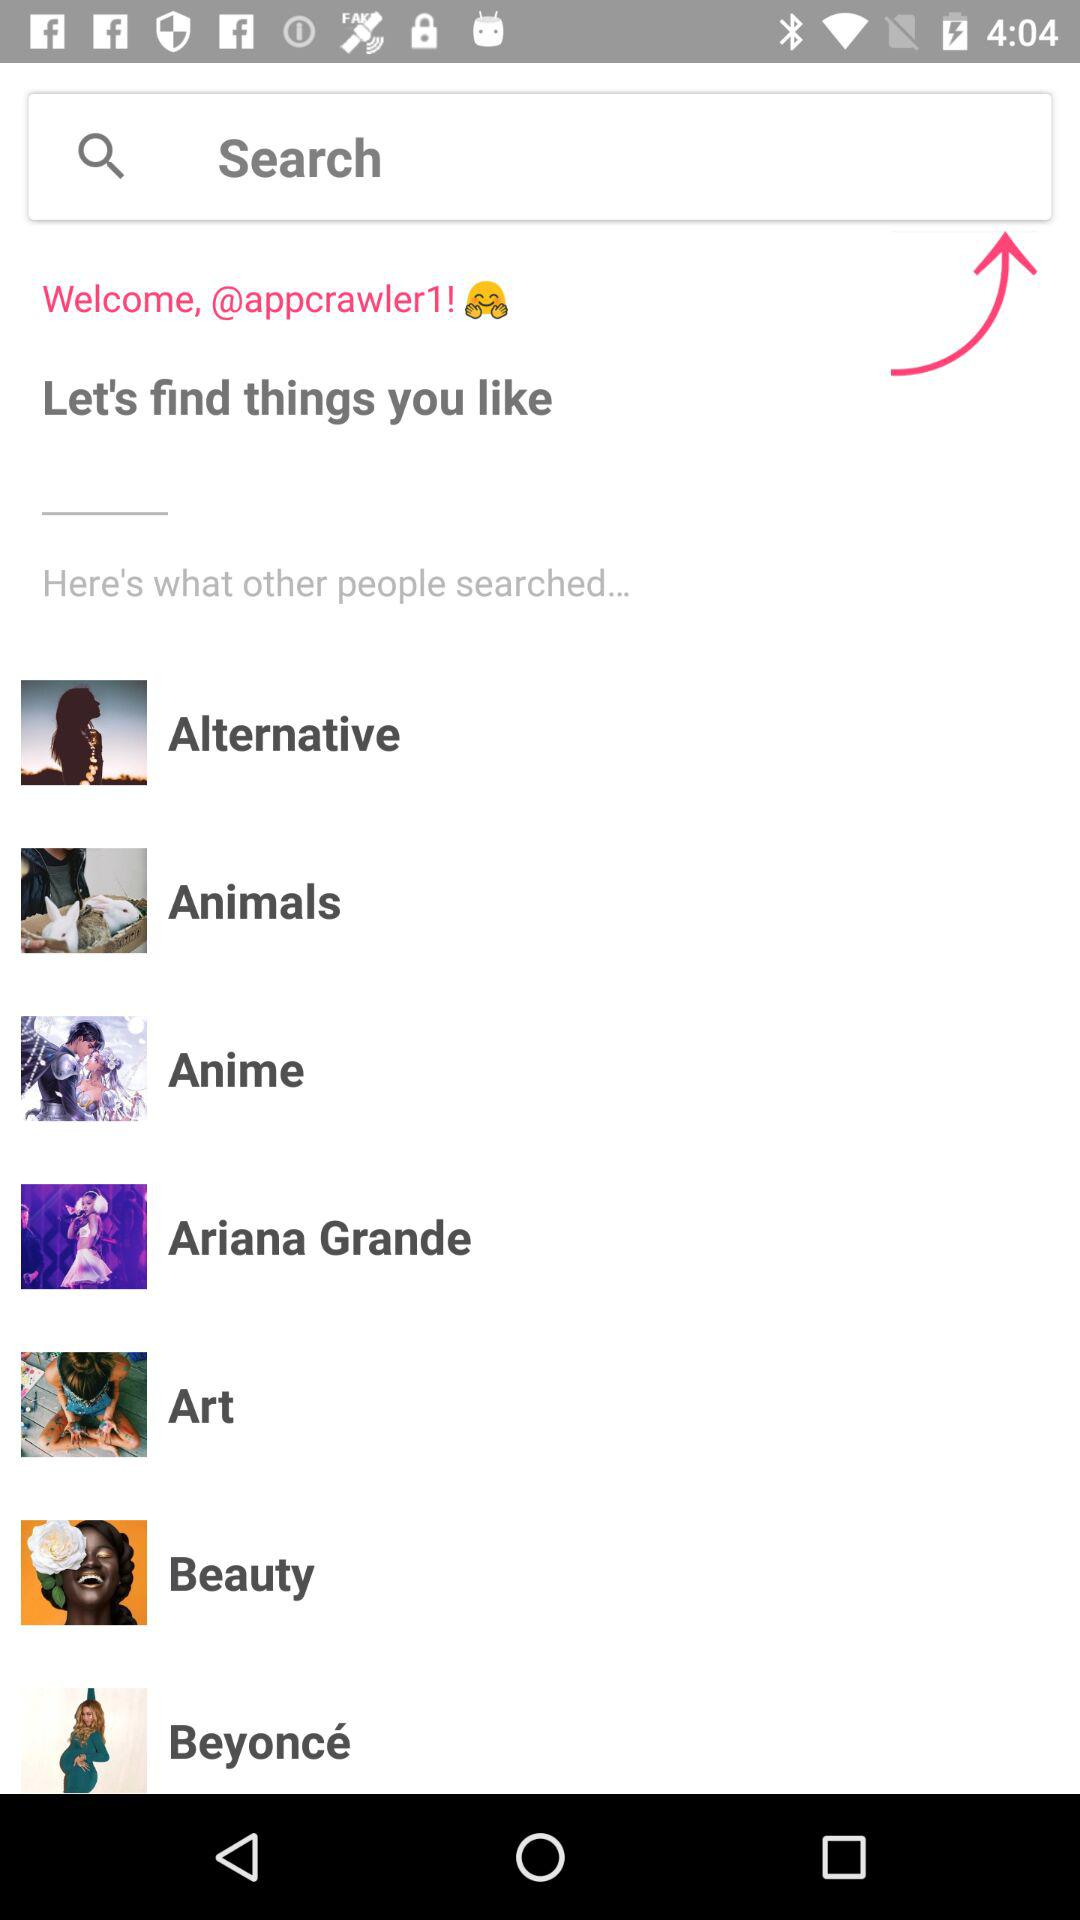What is the username? The username is "appcrawler1". 